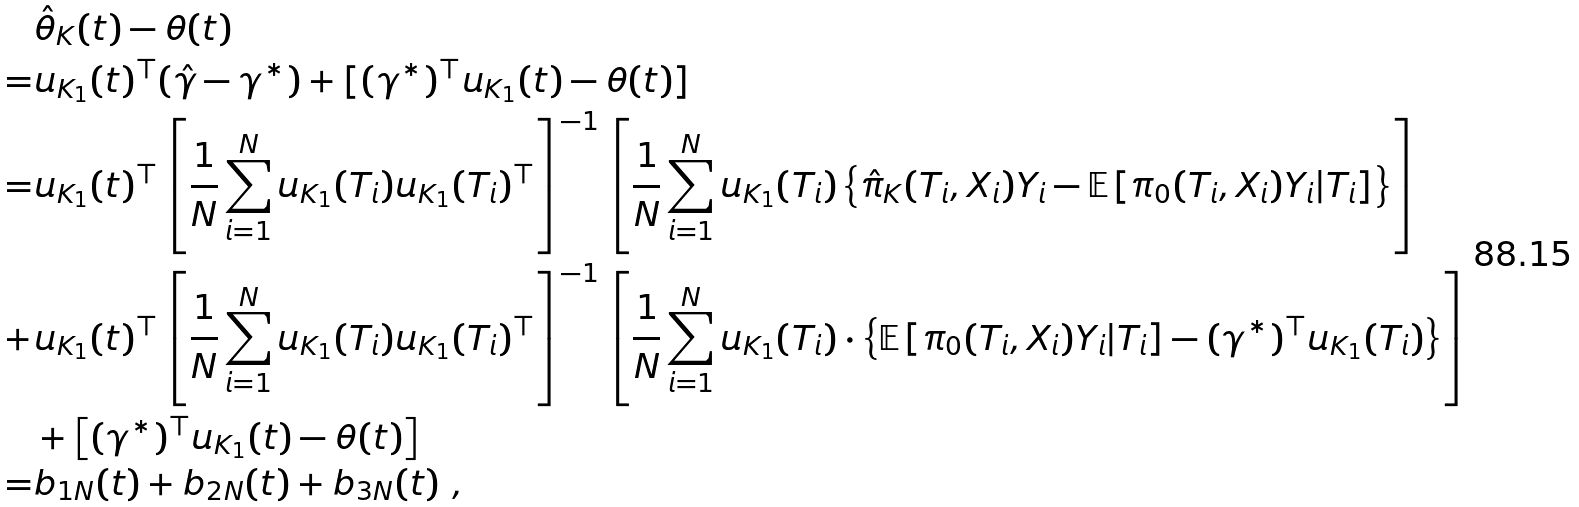<formula> <loc_0><loc_0><loc_500><loc_500>& \hat { \theta } _ { K } ( t ) - \theta ( t ) \\ = & u _ { K _ { 1 } } ( t ) ^ { \top } ( \hat { \gamma } - \gamma ^ { * } ) + [ ( \gamma ^ { * } ) ^ { \top } u _ { K _ { 1 } } ( t ) - \theta ( t ) ] \\ = & u _ { K _ { 1 } } ( t ) ^ { \top } \left [ \frac { 1 } { N } \sum _ { i = 1 } ^ { N } u _ { K _ { 1 } } ( T _ { i } ) u _ { K _ { 1 } } ( T _ { i } ) ^ { \top } \right ] ^ { - 1 } \left [ \frac { 1 } { N } \sum _ { i = 1 } ^ { N } u _ { K _ { 1 } } ( T _ { i } ) \left \{ \hat { \pi } _ { K } ( T _ { i } , X _ { i } ) Y _ { i } - \mathbb { E } \left [ { \pi } _ { 0 } ( T _ { i } , X _ { i } ) Y _ { i } | T _ { i } \right ] \right \} \right ] \\ + & u _ { K _ { 1 } } ( t ) ^ { \top } \left [ \frac { 1 } { N } \sum _ { i = 1 } ^ { N } u _ { K _ { 1 } } ( T _ { i } ) u _ { K _ { 1 } } ( T _ { i } ) ^ { \top } \right ] ^ { - 1 } \left [ \frac { 1 } { N } \sum _ { i = 1 } ^ { N } u _ { K _ { 1 } } ( T _ { i } ) \cdot \left \{ \mathbb { E } \left [ { \pi } _ { 0 } ( T _ { i } , X _ { i } ) Y _ { i } | T _ { i } \right ] - ( \gamma ^ { * } ) ^ { \top } u _ { K _ { 1 } } ( T _ { i } ) \right \} \right ] \\ & + \left [ ( \gamma ^ { * } ) ^ { \top } u _ { K _ { 1 } } ( t ) - \theta ( t ) \right ] \\ = & b _ { 1 N } ( t ) + b _ { 2 N } ( t ) + b _ { 3 N } ( t ) \ ,</formula> 